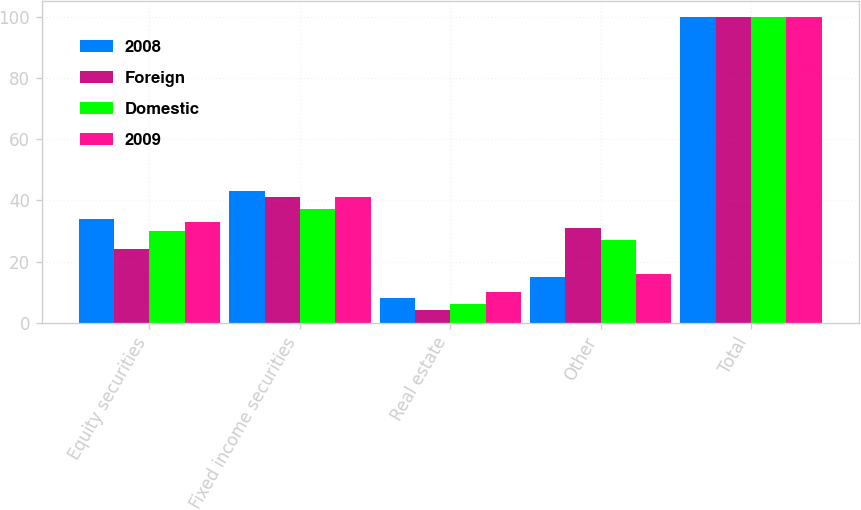Convert chart to OTSL. <chart><loc_0><loc_0><loc_500><loc_500><stacked_bar_chart><ecel><fcel>Equity securities<fcel>Fixed income securities<fcel>Real estate<fcel>Other<fcel>Total<nl><fcel>2008<fcel>34<fcel>43<fcel>8<fcel>15<fcel>100<nl><fcel>Foreign<fcel>24<fcel>41<fcel>4<fcel>31<fcel>100<nl><fcel>Domestic<fcel>30<fcel>37<fcel>6<fcel>27<fcel>100<nl><fcel>2009<fcel>33<fcel>41<fcel>10<fcel>16<fcel>100<nl></chart> 